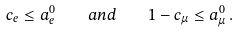Convert formula to latex. <formula><loc_0><loc_0><loc_500><loc_500>c _ { e } \leq a ^ { 0 } _ { e } \quad a n d \quad 1 - c _ { \mu } \leq a ^ { 0 } _ { \mu } \, .</formula> 